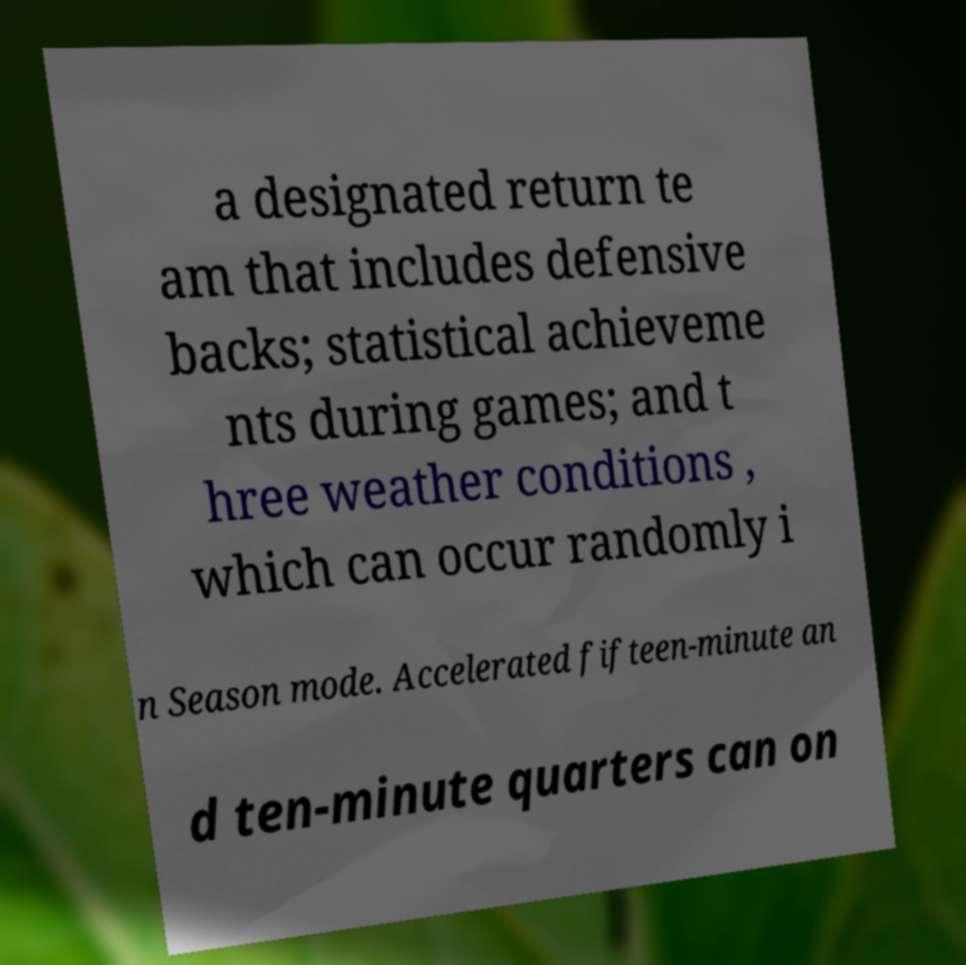What messages or text are displayed in this image? I need them in a readable, typed format. a designated return te am that includes defensive backs; statistical achieveme nts during games; and t hree weather conditions , which can occur randomly i n Season mode. Accelerated fifteen-minute an d ten-minute quarters can on 